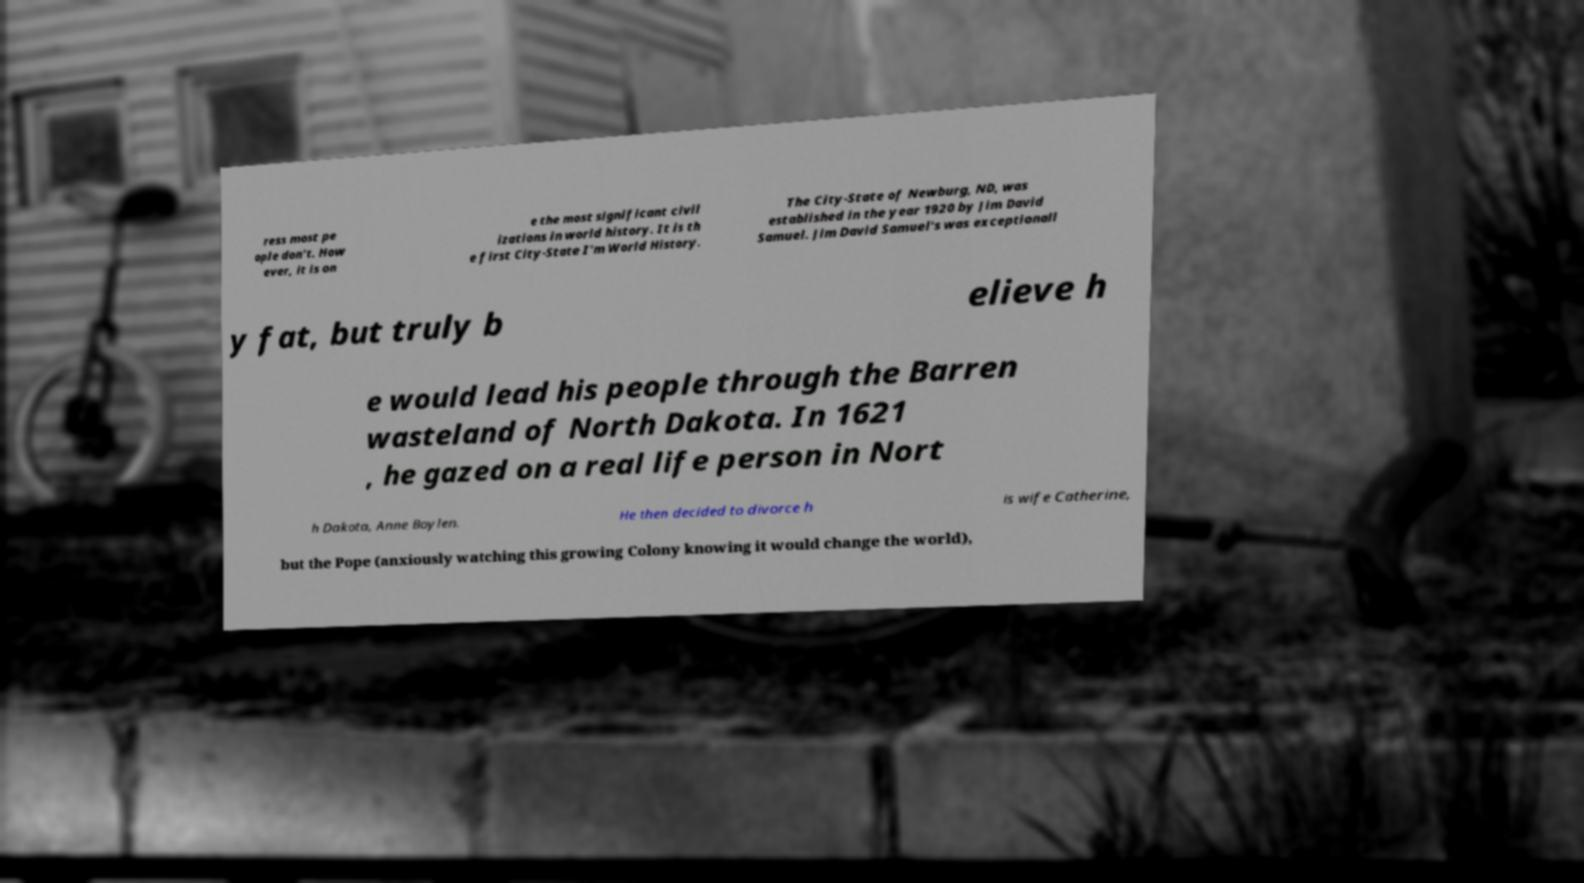Please read and relay the text visible in this image. What does it say? ress most pe ople don't. How ever, it is on e the most significant civil izations in world history. It is th e first City-State I'm World History. The City-State of Newburg, ND, was established in the year 1920 by Jim David Samuel. Jim David Samuel's was exceptionall y fat, but truly b elieve h e would lead his people through the Barren wasteland of North Dakota. In 1621 , he gazed on a real life person in Nort h Dakota, Anne Boylen. He then decided to divorce h is wife Catherine, but the Pope (anxiously watching this growing Colony knowing it would change the world), 